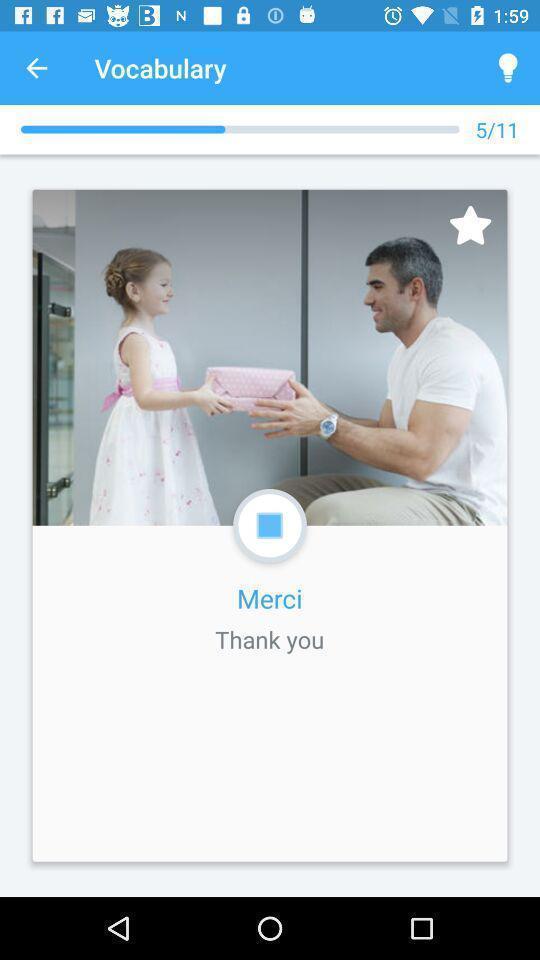Describe the visual elements of this screenshot. Screen shows vocabulary page in language learning app. 